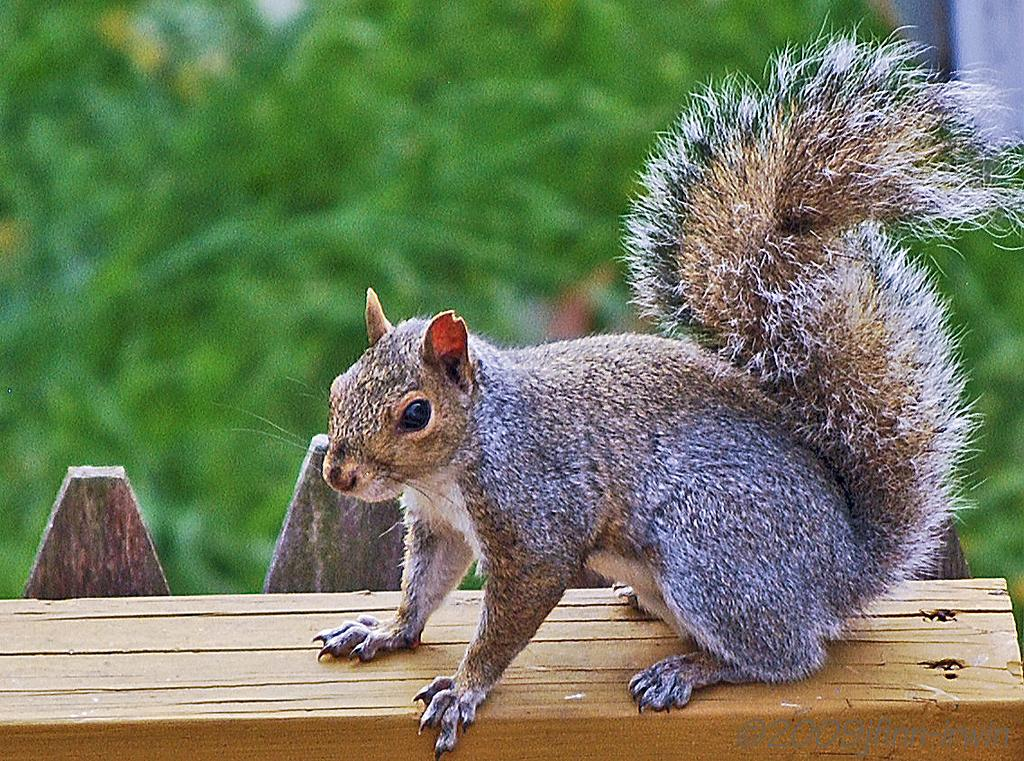What animal is present in the image? There is a squirrel in the image. What type of surface is the squirrel on? The squirrel is on a wooden floor. What can be seen in the background of the image? There are plants visible in the background of the image. What color is the tent in the image? There is no tent present in the image. 